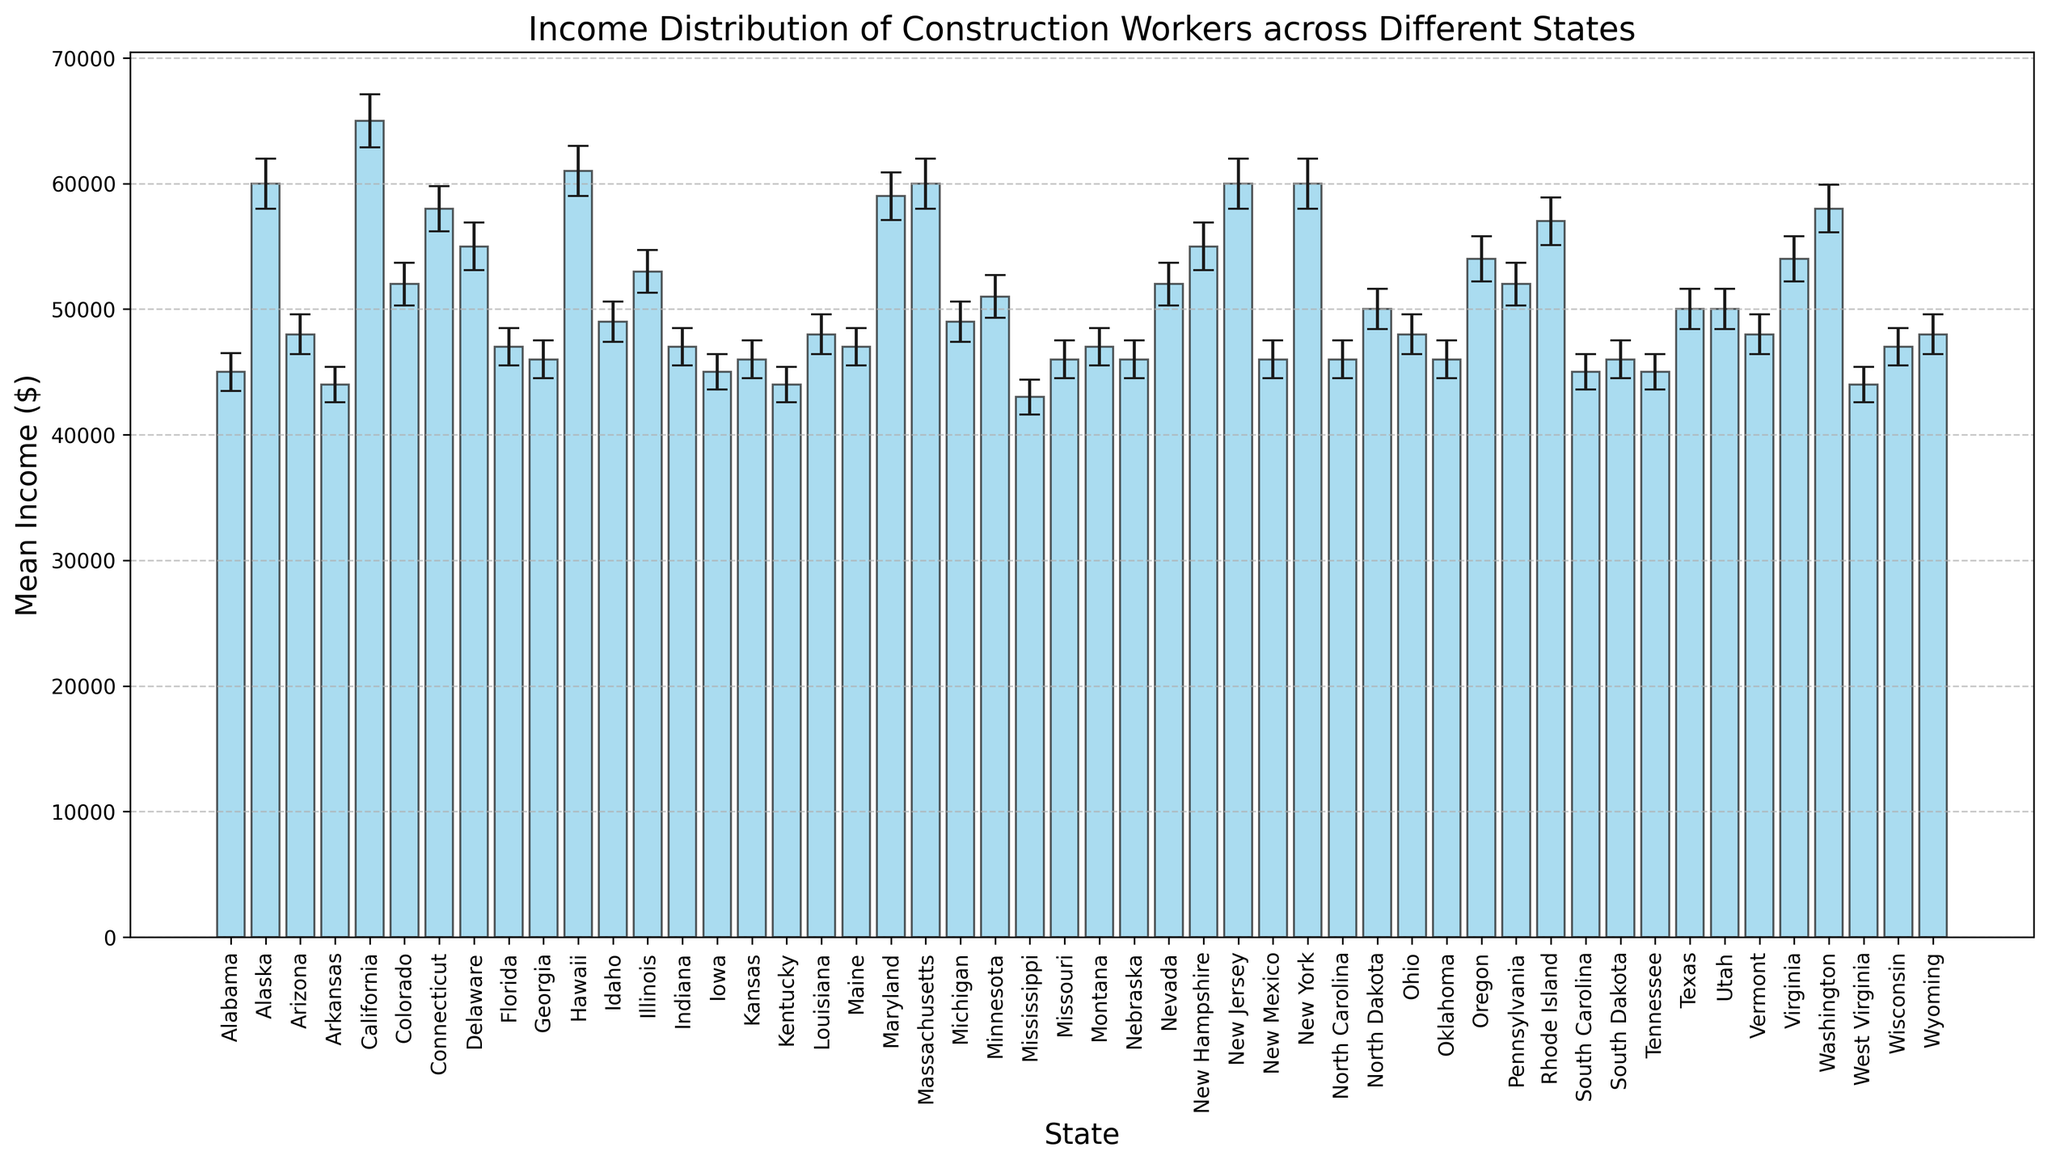What is the mean income of construction workers in California? The mean income of construction workers in California is shown by the height of the bar labeled "California." The height reaches $65,000.
Answer: $65,000 Which state has the lowest mean income for construction workers? Among all the bars, the shortest one represents the state with the lowest mean income. The bar for Mississippi is the shortest, with a mean income of $43,000.
Answer: Mississippi Compare the mean income of construction workers in Texas and New Mexico. Which state has a higher mean income, and by how much? First, identify the bars for Texas and New Mexico. The bar for Texas corresponds to $50,000, and the bar for New Mexico corresponds to $46,000. Subtract the mean income of New Mexico from Texas: $50,000 - $46,000 = $4,000.
Answer: Texas, $4,000 What is the range of the mean income for construction workers across all states shown in the figure? To find the range, identify the highest and lowest mean incomes in the figure. The highest is California at $65,000, and the lowest is Mississippi at $43,000. Subtract the lowest from the highest: $65,000 - $43,000 = $22,000.
Answer: $22,000 Which states have a mean income for construction workers above $55,000? Look for bars that are above the $55,000 mark. The states with mean incomes above this threshold are California, Alaska, Hawaii, Massachusetts, New Jersey, and New York.
Answer: California, Alaska, Hawaii, Massachusetts, New Jersey, New York What is the difference in mean income between the states with the highest and lowest incomes for construction workers? Identify the highest and lowest incomes: California has the highest at $65,000, and Mississippi has the lowest at $43,000. Subtract the lowest from the highest: $65,000 - $43,000 = $22,000.
Answer: $22,000 What can be said about the error margins in Alaska and New Jersey? The bars for Alaska and New Jersey show the error margins as vertical lines. Both Alaska and New Jersey have error margins of $2,000, as indicated in the figure by the length of the error bars.
Answer: Both $2,000 Which states have mean incomes closest to the overall average mean income for all states shown? Calculate the overall average first by averaging all the mean incomes. Then, identify which states have mean incomes closest to this average. (Due to complexity, for simplicity's sake, the specific states would depend on detailed calculations.)
Answer: Varies 